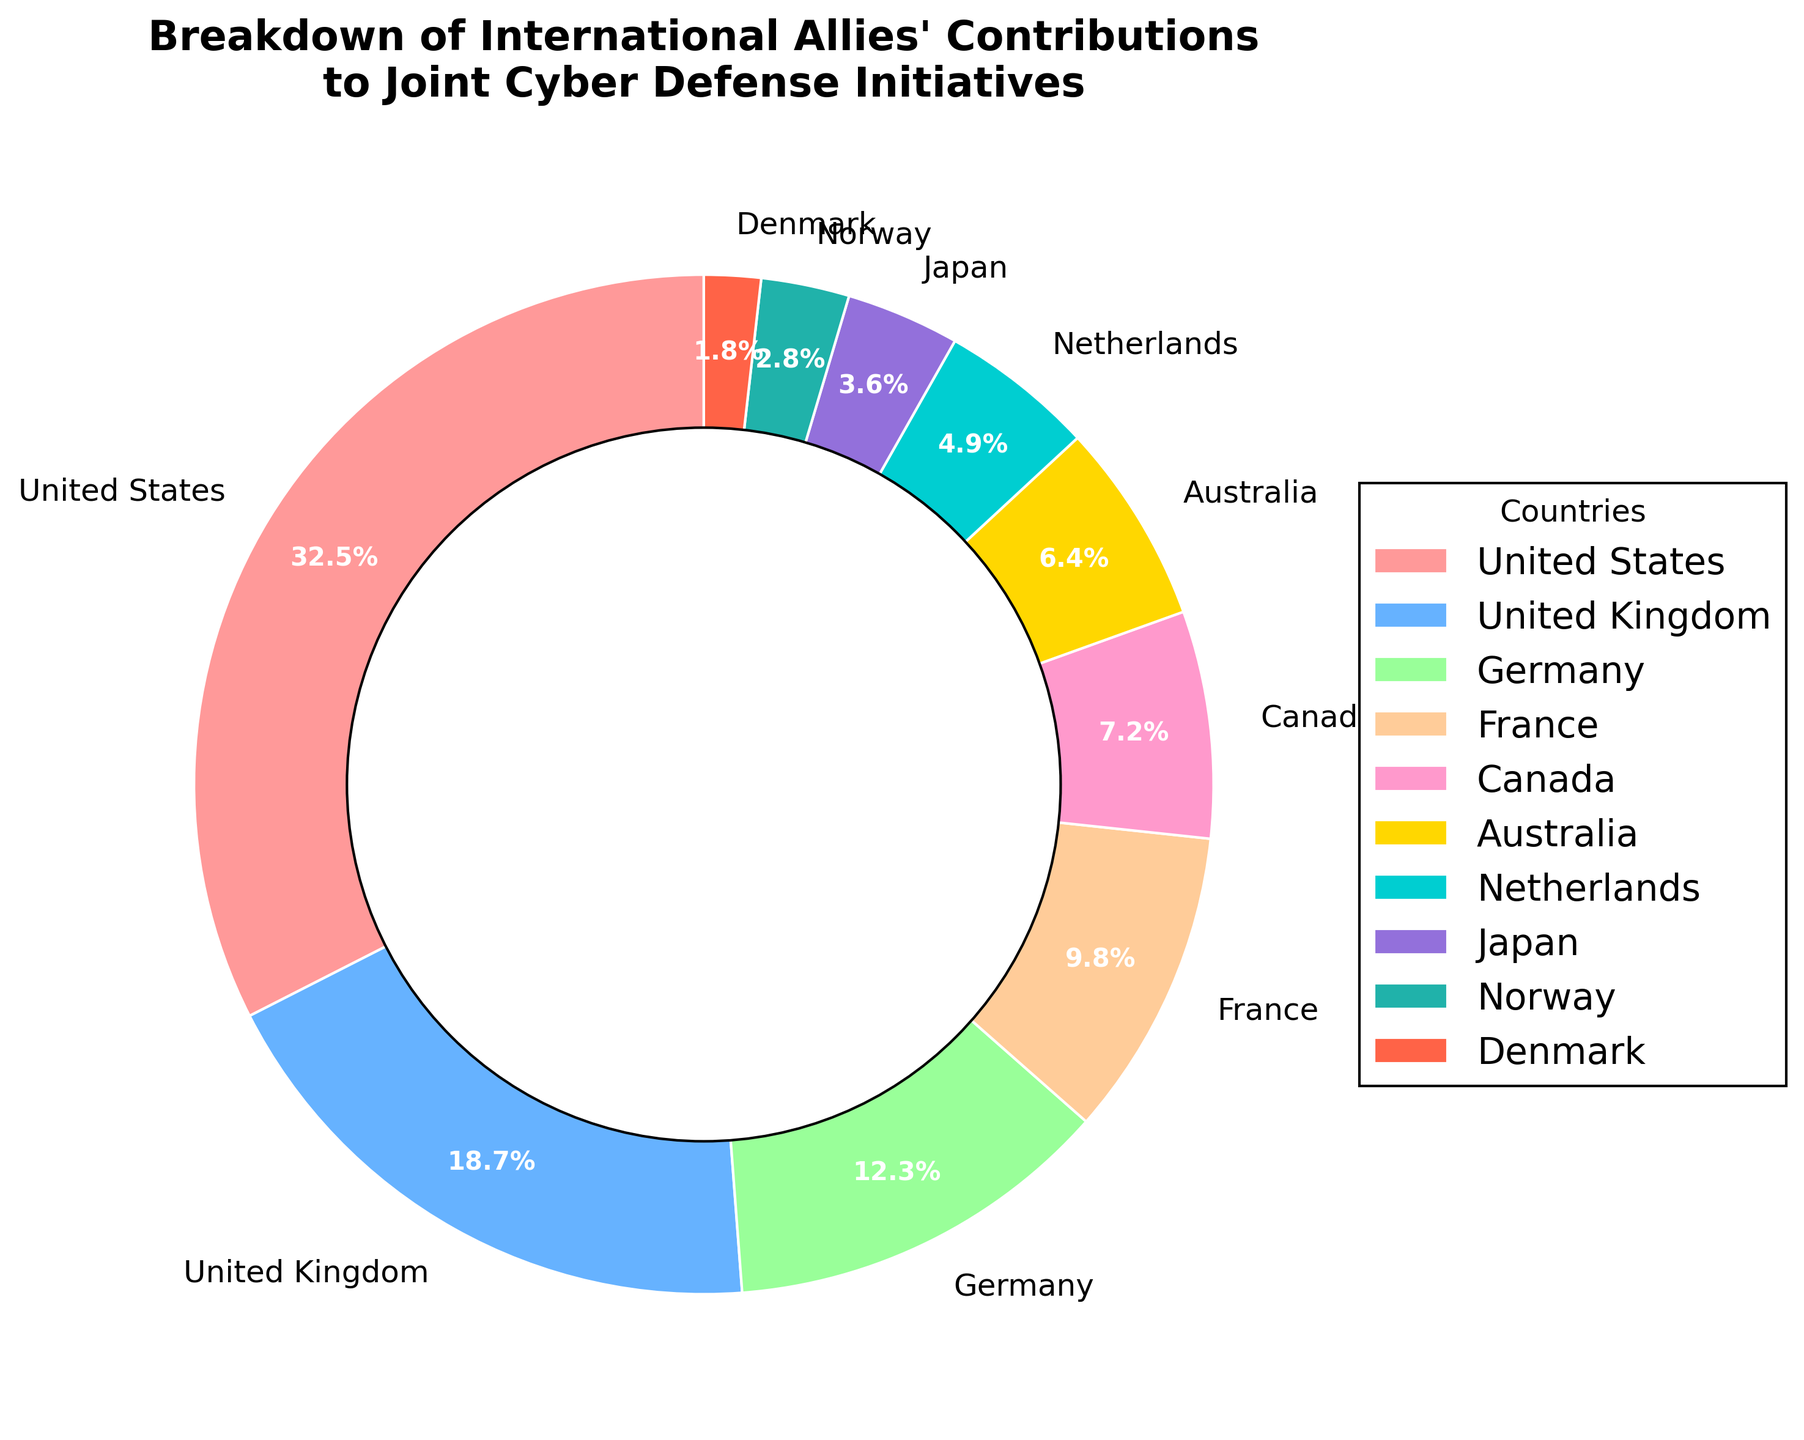Which country contributes the most to the joint cyber defense initiatives? The figure shows the contribution percentages of various countries. The United States has the largest slice in the pie chart.
Answer: United States What is the combined contribution percentage of Canada and Australia? From the figure, Canada contributes 7.2% and Australia contributes 6.4%. Adding these values, 7.2 + 6.4 = 13.6%.
Answer: 13.6% Which country has a larger contribution, Japan or the Netherlands? Looking at the values on the pie chart, the Netherlands has a contribution of 4.9%, whereas Japan has a contribution of 3.6%.
Answer: Netherlands What is the difference in contribution percentage between the United States and the United Kingdom? The United States contributes 32.5%, and the United Kingdom contributes 18.7%. The difference is 32.5 - 18.7 = 13.8%.
Answer: 13.8% How many countries contribute less than 5%? From the figure, the countries with contributions less than 5% are the Netherlands (4.9%), Japan (3.6%), Norway (2.8%), and Denmark (1.8%). This totals 4 countries.
Answer: 4 Which country contributes the least? The smallest slice in the pie chart is labeled with Denmark's contribution of 1.8%.
Answer: Denmark What is the total contribution of European countries listed (United Kingdom, Germany, France, Netherlands, Norway, Denmark)? The contribution percentages are: United Kingdom 18.7%, Germany 12.3%, France 9.8%, Netherlands 4.9%, Norway 2.8%, and Denmark 1.8%. Summing these gives 18.7 + 12.3 + 9.8 + 4.9 + 2.8 + 1.8 = 50.3%.
Answer: 50.3% Which two countries together contribute approximately 20%? From the figure, considering combinations, the United Kingdom at 18.7% and Denmark at 1.8% give a close approximation of 18.7 + 1.8 = 20.5%.
Answer: United Kingdom and Denmark Is Canada's contribution greater than France's? From the figure, Canada contributes 7.2%, while France contributes 9.8%. Thus, Canada contributes less than France.
Answer: No 